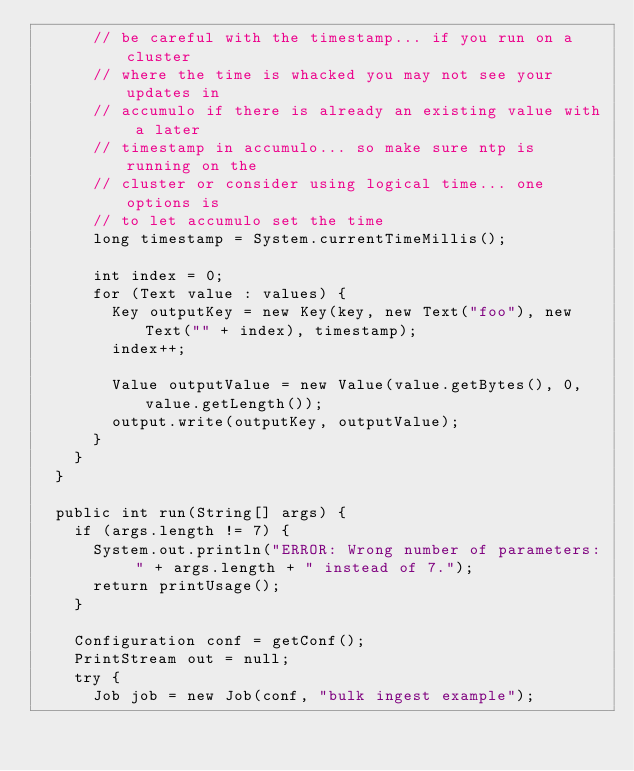Convert code to text. <code><loc_0><loc_0><loc_500><loc_500><_Java_>      // be careful with the timestamp... if you run on a cluster
      // where the time is whacked you may not see your updates in
      // accumulo if there is already an existing value with a later
      // timestamp in accumulo... so make sure ntp is running on the
      // cluster or consider using logical time... one options is
      // to let accumulo set the time
      long timestamp = System.currentTimeMillis();
      
      int index = 0;
      for (Text value : values) {
        Key outputKey = new Key(key, new Text("foo"), new Text("" + index), timestamp);
        index++;
        
        Value outputValue = new Value(value.getBytes(), 0, value.getLength());
        output.write(outputKey, outputValue);
      }
    }
  }
  
  public int run(String[] args) {
    if (args.length != 7) {
      System.out.println("ERROR: Wrong number of parameters: " + args.length + " instead of 7.");
      return printUsage();
    }
    
    Configuration conf = getConf();
    PrintStream out = null;
    try {
      Job job = new Job(conf, "bulk ingest example");</code> 